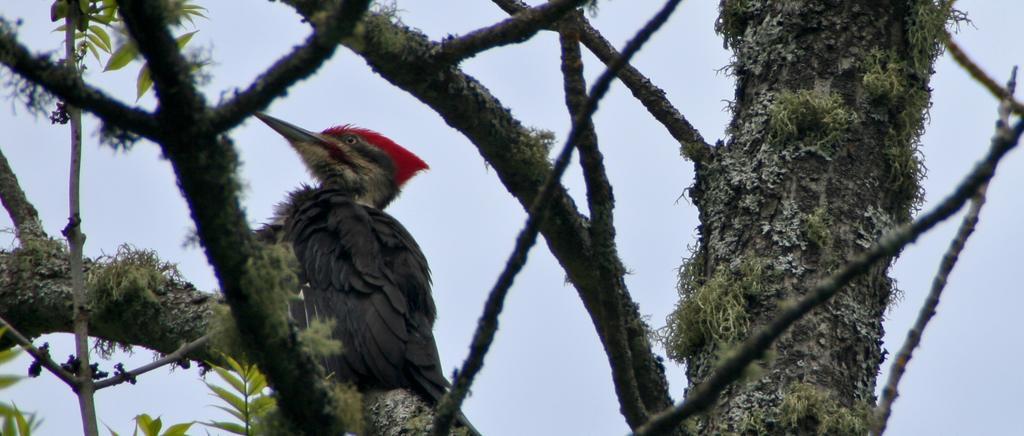How would you summarize this image in a sentence or two? In this picture I can see branches and leaves. I can see a bird on the branch, and in the background there is the sky. 